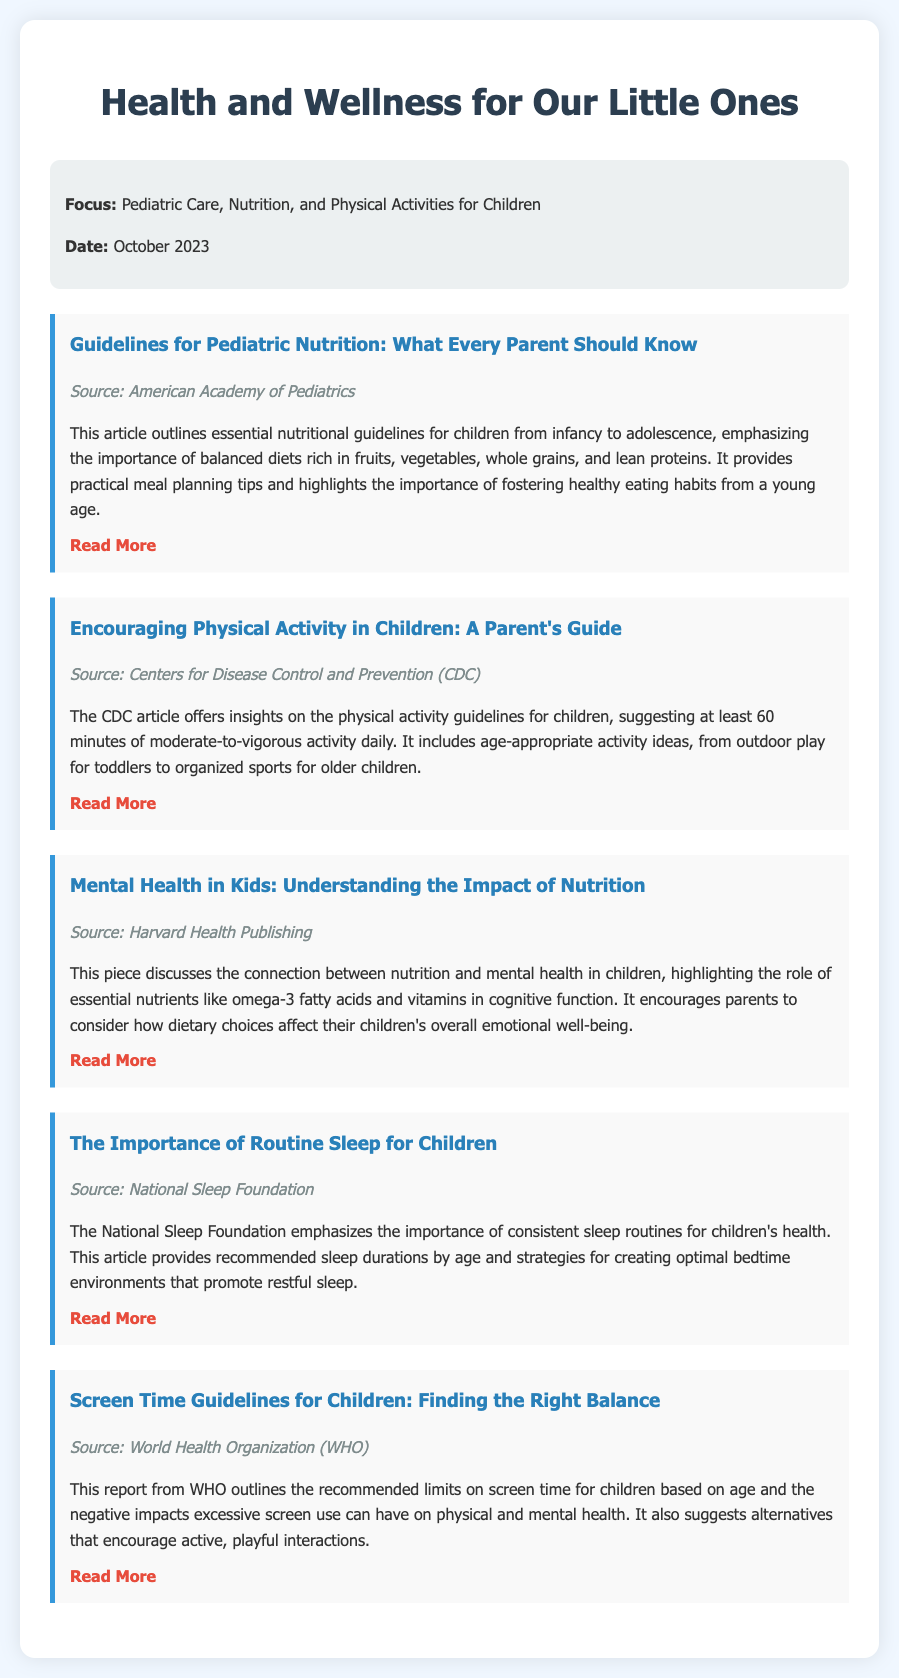What is the focus of the memo? The memo focuses on important topics related to children's health and wellness, specifically in pediatric care, nutrition, and physical activities.
Answer: Pediatric Care, Nutrition, and Physical Activities When was the memo published? The date indicated in the memo marks when the information was compiled and made available to parents.
Answer: October 2023 Which organization provided the guidelines for pediatric nutrition? The source of the guidelines for pediatric nutrition is clearly mentioned in the article title, identifying the authority behind the information.
Answer: American Academy of Pediatrics How many hours of physical activity are recommended daily for children? The article from the CDC outlines a minimum time requirement for physical activity, reflecting guidelines set for children.
Answer: 60 minutes What nutrient is highlighted as important for children's cognitive function? This article discusses specific nutrients that play a significant role in mental health and is essential for children's development and cognitive abilities.
Answer: Omega-3 fatty acids What does the National Sleep Foundation emphasize for children's health? The emphasis in this article points to sleep routines and their significance in maintaining children's overall well-being.
Answer: Consistent sleep routines Which organization outlines screen time guidelines for children? The article discussing screen time limits identifies a prominent organization that sets health recommendations for children.
Answer: World Health Organization What type of activities does the CDC suggest for toddlers? The source explains suitable activities for children at varying ages, including younger age groups like toddlers.
Answer: Outdoor play 